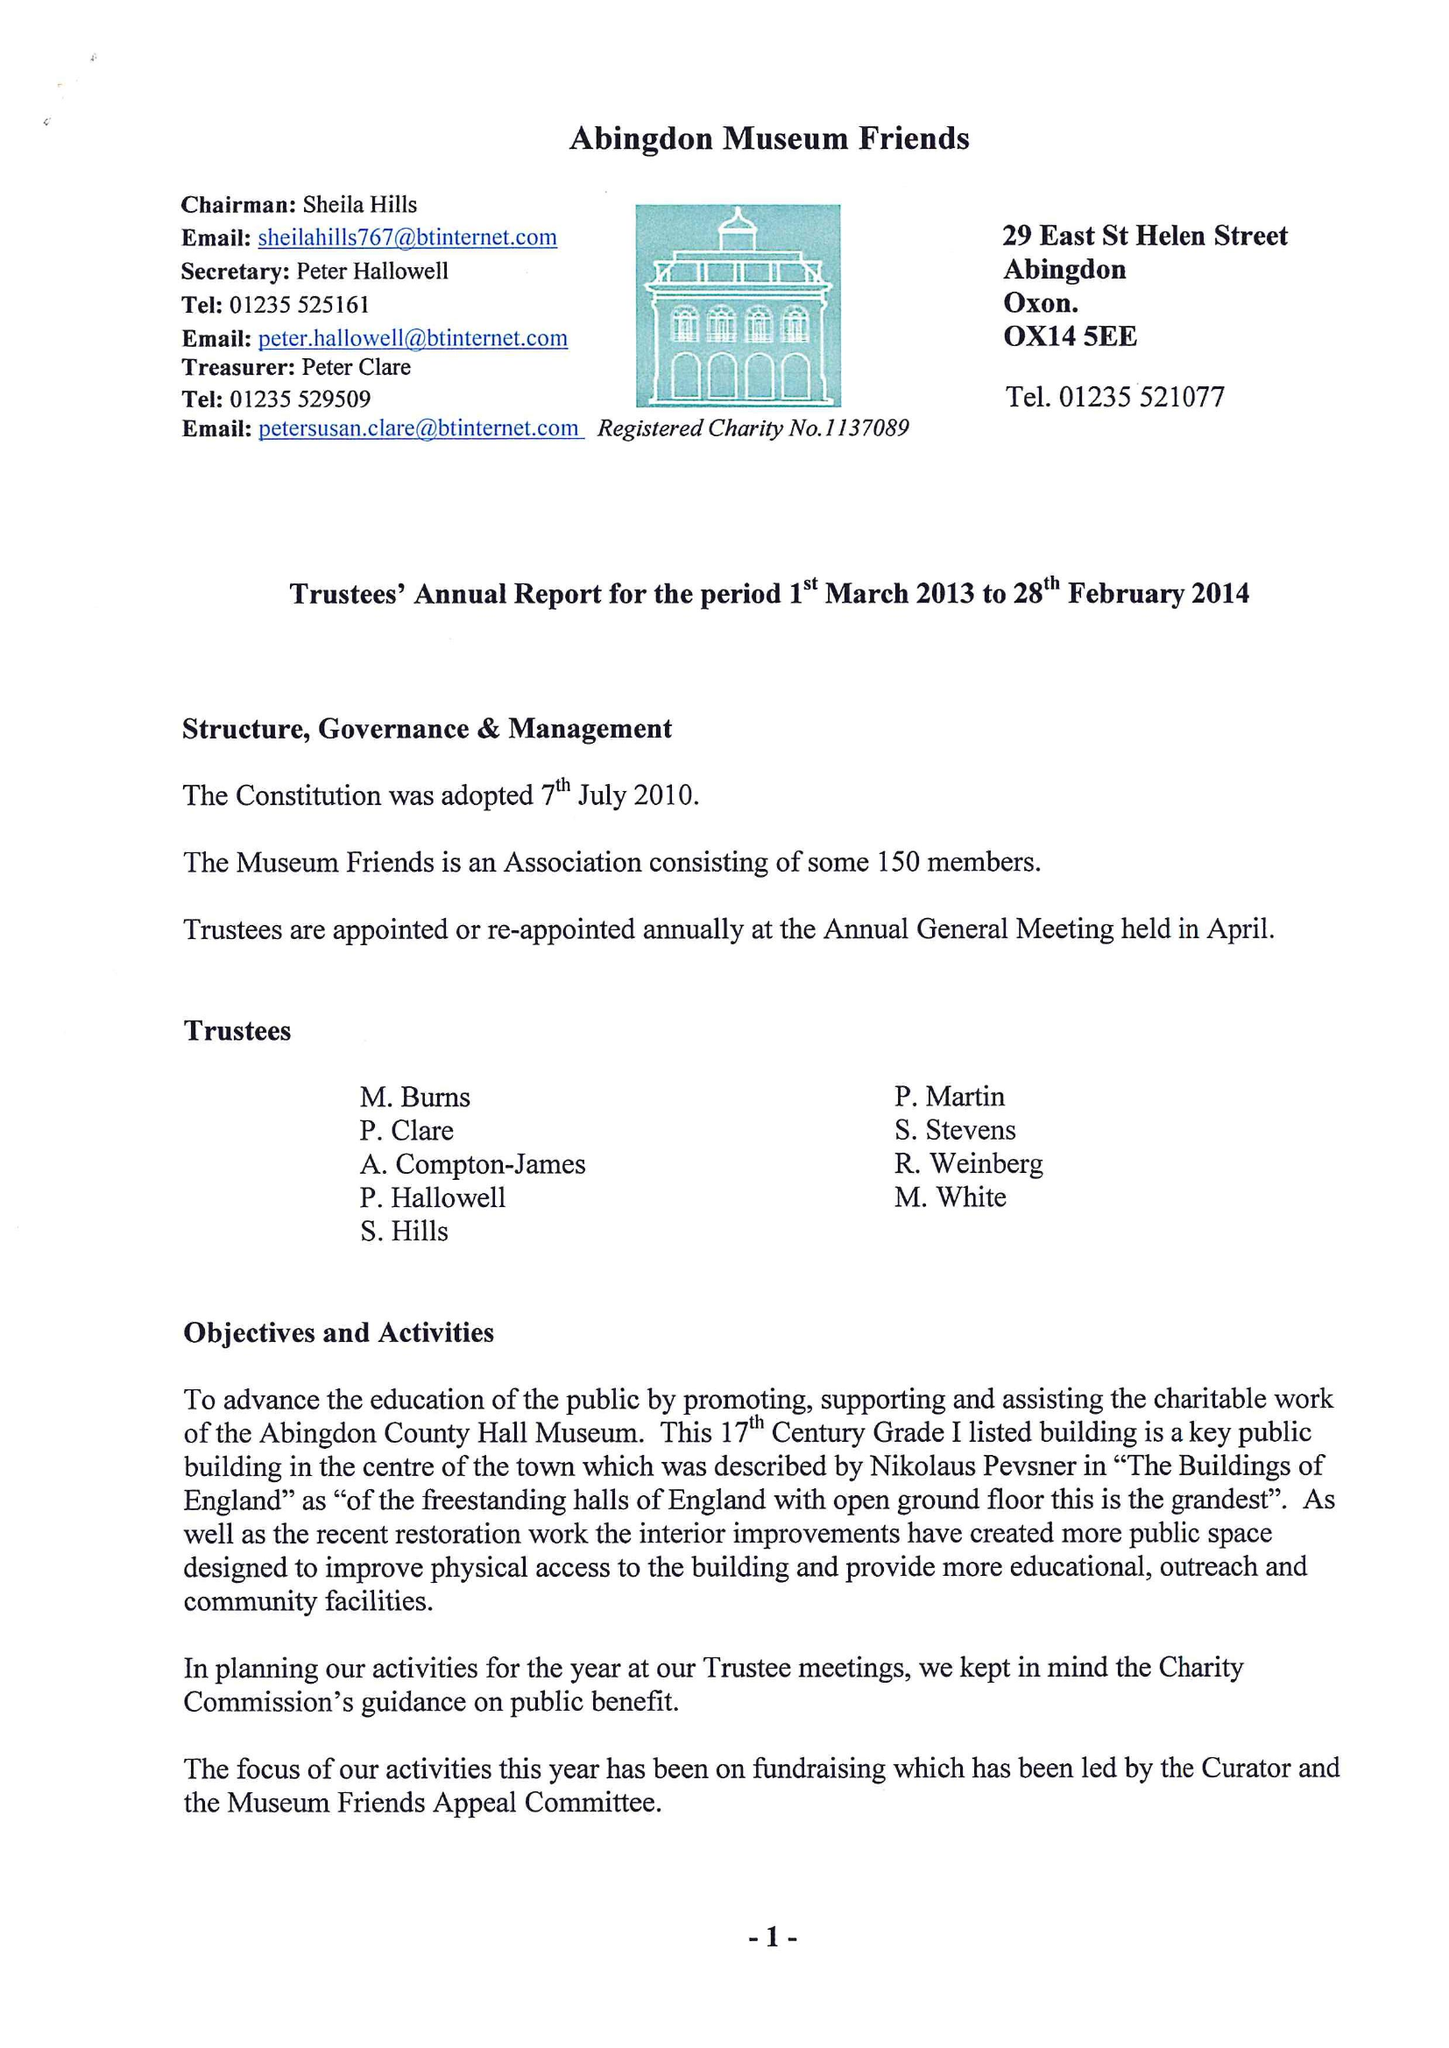What is the value for the address__street_line?
Answer the question using a single word or phrase. 24 WOOTTON ROAD 